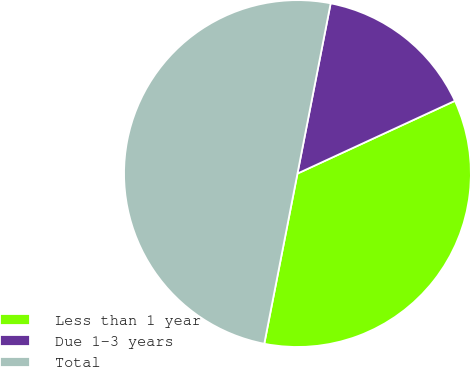Convert chart to OTSL. <chart><loc_0><loc_0><loc_500><loc_500><pie_chart><fcel>Less than 1 year<fcel>Due 1-3 years<fcel>Total<nl><fcel>34.95%<fcel>15.05%<fcel>50.0%<nl></chart> 